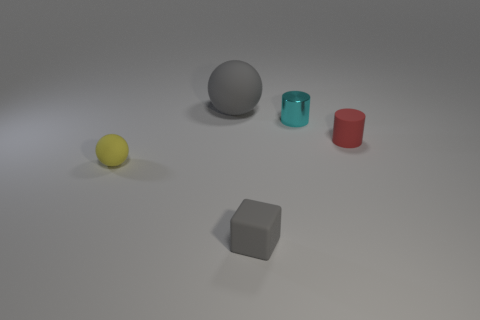Subtract all cubes. How many objects are left? 4 Subtract 1 cylinders. How many cylinders are left? 1 Add 1 cyan blocks. How many objects exist? 6 Subtract all cyan cylinders. How many cylinders are left? 1 Add 1 small red matte balls. How many small red matte balls exist? 1 Subtract 0 blue cubes. How many objects are left? 5 Subtract all red blocks. Subtract all cyan balls. How many blocks are left? 1 Subtract all cyan blocks. How many gray balls are left? 1 Subtract all large gray spheres. Subtract all cylinders. How many objects are left? 2 Add 1 gray spheres. How many gray spheres are left? 2 